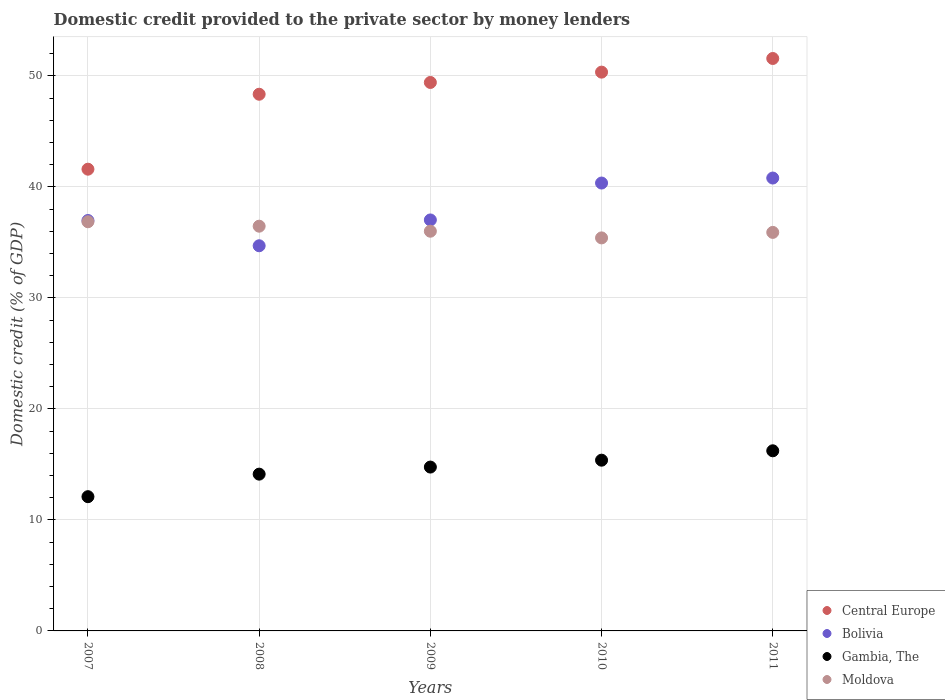What is the domestic credit provided to the private sector by money lenders in Moldova in 2011?
Ensure brevity in your answer.  35.9. Across all years, what is the maximum domestic credit provided to the private sector by money lenders in Central Europe?
Offer a terse response. 51.56. Across all years, what is the minimum domestic credit provided to the private sector by money lenders in Bolivia?
Provide a succinct answer. 34.69. What is the total domestic credit provided to the private sector by money lenders in Moldova in the graph?
Ensure brevity in your answer.  180.61. What is the difference between the domestic credit provided to the private sector by money lenders in Central Europe in 2008 and that in 2011?
Your answer should be compact. -3.22. What is the difference between the domestic credit provided to the private sector by money lenders in Gambia, The in 2009 and the domestic credit provided to the private sector by money lenders in Moldova in 2008?
Make the answer very short. -21.7. What is the average domestic credit provided to the private sector by money lenders in Central Europe per year?
Your answer should be very brief. 48.25. In the year 2007, what is the difference between the domestic credit provided to the private sector by money lenders in Moldova and domestic credit provided to the private sector by money lenders in Gambia, The?
Make the answer very short. 24.76. In how many years, is the domestic credit provided to the private sector by money lenders in Bolivia greater than 24 %?
Provide a short and direct response. 5. What is the ratio of the domestic credit provided to the private sector by money lenders in Moldova in 2007 to that in 2010?
Your response must be concise. 1.04. Is the domestic credit provided to the private sector by money lenders in Central Europe in 2007 less than that in 2011?
Your answer should be very brief. Yes. Is the difference between the domestic credit provided to the private sector by money lenders in Moldova in 2007 and 2008 greater than the difference between the domestic credit provided to the private sector by money lenders in Gambia, The in 2007 and 2008?
Keep it short and to the point. Yes. What is the difference between the highest and the second highest domestic credit provided to the private sector by money lenders in Gambia, The?
Provide a short and direct response. 0.85. What is the difference between the highest and the lowest domestic credit provided to the private sector by money lenders in Central Europe?
Your answer should be compact. 9.97. In how many years, is the domestic credit provided to the private sector by money lenders in Gambia, The greater than the average domestic credit provided to the private sector by money lenders in Gambia, The taken over all years?
Offer a terse response. 3. Is the sum of the domestic credit provided to the private sector by money lenders in Moldova in 2010 and 2011 greater than the maximum domestic credit provided to the private sector by money lenders in Central Europe across all years?
Your answer should be compact. Yes. Is it the case that in every year, the sum of the domestic credit provided to the private sector by money lenders in Bolivia and domestic credit provided to the private sector by money lenders in Gambia, The  is greater than the domestic credit provided to the private sector by money lenders in Moldova?
Your answer should be very brief. Yes. Is the domestic credit provided to the private sector by money lenders in Bolivia strictly less than the domestic credit provided to the private sector by money lenders in Moldova over the years?
Ensure brevity in your answer.  No. How many years are there in the graph?
Your answer should be very brief. 5. What is the difference between two consecutive major ticks on the Y-axis?
Offer a terse response. 10. Does the graph contain any zero values?
Make the answer very short. No. Does the graph contain grids?
Give a very brief answer. Yes. How are the legend labels stacked?
Your answer should be very brief. Vertical. What is the title of the graph?
Offer a very short reply. Domestic credit provided to the private sector by money lenders. Does "American Samoa" appear as one of the legend labels in the graph?
Your response must be concise. No. What is the label or title of the Y-axis?
Offer a terse response. Domestic credit (% of GDP). What is the Domestic credit (% of GDP) of Central Europe in 2007?
Give a very brief answer. 41.59. What is the Domestic credit (% of GDP) in Bolivia in 2007?
Give a very brief answer. 36.97. What is the Domestic credit (% of GDP) in Gambia, The in 2007?
Ensure brevity in your answer.  12.09. What is the Domestic credit (% of GDP) in Moldova in 2007?
Offer a very short reply. 36.86. What is the Domestic credit (% of GDP) in Central Europe in 2008?
Your answer should be compact. 48.34. What is the Domestic credit (% of GDP) in Bolivia in 2008?
Provide a succinct answer. 34.69. What is the Domestic credit (% of GDP) of Gambia, The in 2008?
Your answer should be very brief. 14.12. What is the Domestic credit (% of GDP) of Moldova in 2008?
Offer a terse response. 36.46. What is the Domestic credit (% of GDP) in Central Europe in 2009?
Provide a succinct answer. 49.4. What is the Domestic credit (% of GDP) of Bolivia in 2009?
Give a very brief answer. 37.02. What is the Domestic credit (% of GDP) of Gambia, The in 2009?
Your answer should be compact. 14.76. What is the Domestic credit (% of GDP) in Moldova in 2009?
Your response must be concise. 36. What is the Domestic credit (% of GDP) in Central Europe in 2010?
Make the answer very short. 50.33. What is the Domestic credit (% of GDP) in Bolivia in 2010?
Offer a very short reply. 40.34. What is the Domestic credit (% of GDP) in Gambia, The in 2010?
Provide a succinct answer. 15.38. What is the Domestic credit (% of GDP) of Moldova in 2010?
Keep it short and to the point. 35.4. What is the Domestic credit (% of GDP) of Central Europe in 2011?
Your response must be concise. 51.56. What is the Domestic credit (% of GDP) in Bolivia in 2011?
Ensure brevity in your answer.  40.79. What is the Domestic credit (% of GDP) in Gambia, The in 2011?
Make the answer very short. 16.22. What is the Domestic credit (% of GDP) in Moldova in 2011?
Your answer should be very brief. 35.9. Across all years, what is the maximum Domestic credit (% of GDP) in Central Europe?
Give a very brief answer. 51.56. Across all years, what is the maximum Domestic credit (% of GDP) of Bolivia?
Ensure brevity in your answer.  40.79. Across all years, what is the maximum Domestic credit (% of GDP) in Gambia, The?
Offer a very short reply. 16.22. Across all years, what is the maximum Domestic credit (% of GDP) of Moldova?
Give a very brief answer. 36.86. Across all years, what is the minimum Domestic credit (% of GDP) in Central Europe?
Provide a succinct answer. 41.59. Across all years, what is the minimum Domestic credit (% of GDP) in Bolivia?
Make the answer very short. 34.69. Across all years, what is the minimum Domestic credit (% of GDP) in Gambia, The?
Offer a terse response. 12.09. Across all years, what is the minimum Domestic credit (% of GDP) in Moldova?
Your answer should be compact. 35.4. What is the total Domestic credit (% of GDP) of Central Europe in the graph?
Provide a succinct answer. 241.23. What is the total Domestic credit (% of GDP) in Bolivia in the graph?
Ensure brevity in your answer.  189.81. What is the total Domestic credit (% of GDP) of Gambia, The in the graph?
Make the answer very short. 72.58. What is the total Domestic credit (% of GDP) of Moldova in the graph?
Your response must be concise. 180.61. What is the difference between the Domestic credit (% of GDP) of Central Europe in 2007 and that in 2008?
Your answer should be very brief. -6.75. What is the difference between the Domestic credit (% of GDP) of Bolivia in 2007 and that in 2008?
Make the answer very short. 2.28. What is the difference between the Domestic credit (% of GDP) of Gambia, The in 2007 and that in 2008?
Your answer should be very brief. -2.03. What is the difference between the Domestic credit (% of GDP) in Moldova in 2007 and that in 2008?
Your answer should be very brief. 0.4. What is the difference between the Domestic credit (% of GDP) in Central Europe in 2007 and that in 2009?
Offer a terse response. -7.81. What is the difference between the Domestic credit (% of GDP) in Bolivia in 2007 and that in 2009?
Keep it short and to the point. -0.05. What is the difference between the Domestic credit (% of GDP) of Gambia, The in 2007 and that in 2009?
Keep it short and to the point. -2.67. What is the difference between the Domestic credit (% of GDP) in Moldova in 2007 and that in 2009?
Provide a succinct answer. 0.85. What is the difference between the Domestic credit (% of GDP) of Central Europe in 2007 and that in 2010?
Ensure brevity in your answer.  -8.74. What is the difference between the Domestic credit (% of GDP) of Bolivia in 2007 and that in 2010?
Offer a terse response. -3.37. What is the difference between the Domestic credit (% of GDP) of Gambia, The in 2007 and that in 2010?
Ensure brevity in your answer.  -3.29. What is the difference between the Domestic credit (% of GDP) in Moldova in 2007 and that in 2010?
Offer a terse response. 1.45. What is the difference between the Domestic credit (% of GDP) in Central Europe in 2007 and that in 2011?
Keep it short and to the point. -9.97. What is the difference between the Domestic credit (% of GDP) in Bolivia in 2007 and that in 2011?
Your answer should be compact. -3.82. What is the difference between the Domestic credit (% of GDP) in Gambia, The in 2007 and that in 2011?
Keep it short and to the point. -4.13. What is the difference between the Domestic credit (% of GDP) of Moldova in 2007 and that in 2011?
Your response must be concise. 0.96. What is the difference between the Domestic credit (% of GDP) in Central Europe in 2008 and that in 2009?
Your answer should be compact. -1.06. What is the difference between the Domestic credit (% of GDP) of Bolivia in 2008 and that in 2009?
Offer a terse response. -2.33. What is the difference between the Domestic credit (% of GDP) of Gambia, The in 2008 and that in 2009?
Make the answer very short. -0.64. What is the difference between the Domestic credit (% of GDP) of Moldova in 2008 and that in 2009?
Your answer should be compact. 0.45. What is the difference between the Domestic credit (% of GDP) in Central Europe in 2008 and that in 2010?
Offer a terse response. -1.99. What is the difference between the Domestic credit (% of GDP) in Bolivia in 2008 and that in 2010?
Offer a terse response. -5.65. What is the difference between the Domestic credit (% of GDP) of Gambia, The in 2008 and that in 2010?
Ensure brevity in your answer.  -1.26. What is the difference between the Domestic credit (% of GDP) of Moldova in 2008 and that in 2010?
Offer a very short reply. 1.05. What is the difference between the Domestic credit (% of GDP) in Central Europe in 2008 and that in 2011?
Give a very brief answer. -3.22. What is the difference between the Domestic credit (% of GDP) in Bolivia in 2008 and that in 2011?
Provide a succinct answer. -6.1. What is the difference between the Domestic credit (% of GDP) of Gambia, The in 2008 and that in 2011?
Your answer should be compact. -2.1. What is the difference between the Domestic credit (% of GDP) in Moldova in 2008 and that in 2011?
Provide a short and direct response. 0.56. What is the difference between the Domestic credit (% of GDP) in Central Europe in 2009 and that in 2010?
Provide a short and direct response. -0.93. What is the difference between the Domestic credit (% of GDP) in Bolivia in 2009 and that in 2010?
Your response must be concise. -3.32. What is the difference between the Domestic credit (% of GDP) in Gambia, The in 2009 and that in 2010?
Ensure brevity in your answer.  -0.62. What is the difference between the Domestic credit (% of GDP) of Moldova in 2009 and that in 2010?
Your answer should be compact. 0.6. What is the difference between the Domestic credit (% of GDP) in Central Europe in 2009 and that in 2011?
Offer a very short reply. -2.16. What is the difference between the Domestic credit (% of GDP) of Bolivia in 2009 and that in 2011?
Provide a short and direct response. -3.77. What is the difference between the Domestic credit (% of GDP) of Gambia, The in 2009 and that in 2011?
Offer a very short reply. -1.47. What is the difference between the Domestic credit (% of GDP) in Moldova in 2009 and that in 2011?
Ensure brevity in your answer.  0.11. What is the difference between the Domestic credit (% of GDP) of Central Europe in 2010 and that in 2011?
Your response must be concise. -1.23. What is the difference between the Domestic credit (% of GDP) in Bolivia in 2010 and that in 2011?
Make the answer very short. -0.45. What is the difference between the Domestic credit (% of GDP) in Gambia, The in 2010 and that in 2011?
Your answer should be very brief. -0.85. What is the difference between the Domestic credit (% of GDP) of Moldova in 2010 and that in 2011?
Your response must be concise. -0.5. What is the difference between the Domestic credit (% of GDP) in Central Europe in 2007 and the Domestic credit (% of GDP) in Bolivia in 2008?
Make the answer very short. 6.9. What is the difference between the Domestic credit (% of GDP) of Central Europe in 2007 and the Domestic credit (% of GDP) of Gambia, The in 2008?
Keep it short and to the point. 27.47. What is the difference between the Domestic credit (% of GDP) of Central Europe in 2007 and the Domestic credit (% of GDP) of Moldova in 2008?
Keep it short and to the point. 5.13. What is the difference between the Domestic credit (% of GDP) of Bolivia in 2007 and the Domestic credit (% of GDP) of Gambia, The in 2008?
Keep it short and to the point. 22.85. What is the difference between the Domestic credit (% of GDP) of Bolivia in 2007 and the Domestic credit (% of GDP) of Moldova in 2008?
Offer a very short reply. 0.51. What is the difference between the Domestic credit (% of GDP) in Gambia, The in 2007 and the Domestic credit (% of GDP) in Moldova in 2008?
Offer a very short reply. -24.36. What is the difference between the Domestic credit (% of GDP) in Central Europe in 2007 and the Domestic credit (% of GDP) in Bolivia in 2009?
Provide a short and direct response. 4.57. What is the difference between the Domestic credit (% of GDP) of Central Europe in 2007 and the Domestic credit (% of GDP) of Gambia, The in 2009?
Offer a very short reply. 26.83. What is the difference between the Domestic credit (% of GDP) in Central Europe in 2007 and the Domestic credit (% of GDP) in Moldova in 2009?
Provide a succinct answer. 5.59. What is the difference between the Domestic credit (% of GDP) in Bolivia in 2007 and the Domestic credit (% of GDP) in Gambia, The in 2009?
Keep it short and to the point. 22.21. What is the difference between the Domestic credit (% of GDP) of Bolivia in 2007 and the Domestic credit (% of GDP) of Moldova in 2009?
Give a very brief answer. 0.97. What is the difference between the Domestic credit (% of GDP) in Gambia, The in 2007 and the Domestic credit (% of GDP) in Moldova in 2009?
Give a very brief answer. -23.91. What is the difference between the Domestic credit (% of GDP) of Central Europe in 2007 and the Domestic credit (% of GDP) of Bolivia in 2010?
Provide a succinct answer. 1.25. What is the difference between the Domestic credit (% of GDP) of Central Europe in 2007 and the Domestic credit (% of GDP) of Gambia, The in 2010?
Your response must be concise. 26.21. What is the difference between the Domestic credit (% of GDP) of Central Europe in 2007 and the Domestic credit (% of GDP) of Moldova in 2010?
Your answer should be compact. 6.19. What is the difference between the Domestic credit (% of GDP) in Bolivia in 2007 and the Domestic credit (% of GDP) in Gambia, The in 2010?
Keep it short and to the point. 21.59. What is the difference between the Domestic credit (% of GDP) in Bolivia in 2007 and the Domestic credit (% of GDP) in Moldova in 2010?
Your response must be concise. 1.57. What is the difference between the Domestic credit (% of GDP) of Gambia, The in 2007 and the Domestic credit (% of GDP) of Moldova in 2010?
Give a very brief answer. -23.31. What is the difference between the Domestic credit (% of GDP) of Central Europe in 2007 and the Domestic credit (% of GDP) of Bolivia in 2011?
Make the answer very short. 0.8. What is the difference between the Domestic credit (% of GDP) in Central Europe in 2007 and the Domestic credit (% of GDP) in Gambia, The in 2011?
Provide a short and direct response. 25.37. What is the difference between the Domestic credit (% of GDP) in Central Europe in 2007 and the Domestic credit (% of GDP) in Moldova in 2011?
Your answer should be very brief. 5.69. What is the difference between the Domestic credit (% of GDP) in Bolivia in 2007 and the Domestic credit (% of GDP) in Gambia, The in 2011?
Provide a short and direct response. 20.74. What is the difference between the Domestic credit (% of GDP) in Bolivia in 2007 and the Domestic credit (% of GDP) in Moldova in 2011?
Your answer should be compact. 1.07. What is the difference between the Domestic credit (% of GDP) of Gambia, The in 2007 and the Domestic credit (% of GDP) of Moldova in 2011?
Make the answer very short. -23.8. What is the difference between the Domestic credit (% of GDP) of Central Europe in 2008 and the Domestic credit (% of GDP) of Bolivia in 2009?
Your answer should be very brief. 11.32. What is the difference between the Domestic credit (% of GDP) in Central Europe in 2008 and the Domestic credit (% of GDP) in Gambia, The in 2009?
Provide a short and direct response. 33.58. What is the difference between the Domestic credit (% of GDP) of Central Europe in 2008 and the Domestic credit (% of GDP) of Moldova in 2009?
Keep it short and to the point. 12.34. What is the difference between the Domestic credit (% of GDP) of Bolivia in 2008 and the Domestic credit (% of GDP) of Gambia, The in 2009?
Your answer should be compact. 19.93. What is the difference between the Domestic credit (% of GDP) in Bolivia in 2008 and the Domestic credit (% of GDP) in Moldova in 2009?
Ensure brevity in your answer.  -1.31. What is the difference between the Domestic credit (% of GDP) in Gambia, The in 2008 and the Domestic credit (% of GDP) in Moldova in 2009?
Offer a very short reply. -21.88. What is the difference between the Domestic credit (% of GDP) in Central Europe in 2008 and the Domestic credit (% of GDP) in Bolivia in 2010?
Make the answer very short. 8. What is the difference between the Domestic credit (% of GDP) in Central Europe in 2008 and the Domestic credit (% of GDP) in Gambia, The in 2010?
Give a very brief answer. 32.96. What is the difference between the Domestic credit (% of GDP) in Central Europe in 2008 and the Domestic credit (% of GDP) in Moldova in 2010?
Give a very brief answer. 12.94. What is the difference between the Domestic credit (% of GDP) in Bolivia in 2008 and the Domestic credit (% of GDP) in Gambia, The in 2010?
Offer a very short reply. 19.31. What is the difference between the Domestic credit (% of GDP) of Bolivia in 2008 and the Domestic credit (% of GDP) of Moldova in 2010?
Provide a succinct answer. -0.71. What is the difference between the Domestic credit (% of GDP) of Gambia, The in 2008 and the Domestic credit (% of GDP) of Moldova in 2010?
Make the answer very short. -21.28. What is the difference between the Domestic credit (% of GDP) in Central Europe in 2008 and the Domestic credit (% of GDP) in Bolivia in 2011?
Give a very brief answer. 7.55. What is the difference between the Domestic credit (% of GDP) in Central Europe in 2008 and the Domestic credit (% of GDP) in Gambia, The in 2011?
Ensure brevity in your answer.  32.12. What is the difference between the Domestic credit (% of GDP) in Central Europe in 2008 and the Domestic credit (% of GDP) in Moldova in 2011?
Keep it short and to the point. 12.44. What is the difference between the Domestic credit (% of GDP) in Bolivia in 2008 and the Domestic credit (% of GDP) in Gambia, The in 2011?
Offer a very short reply. 18.47. What is the difference between the Domestic credit (% of GDP) in Bolivia in 2008 and the Domestic credit (% of GDP) in Moldova in 2011?
Your response must be concise. -1.2. What is the difference between the Domestic credit (% of GDP) of Gambia, The in 2008 and the Domestic credit (% of GDP) of Moldova in 2011?
Offer a terse response. -21.77. What is the difference between the Domestic credit (% of GDP) of Central Europe in 2009 and the Domestic credit (% of GDP) of Bolivia in 2010?
Provide a succinct answer. 9.06. What is the difference between the Domestic credit (% of GDP) of Central Europe in 2009 and the Domestic credit (% of GDP) of Gambia, The in 2010?
Offer a terse response. 34.02. What is the difference between the Domestic credit (% of GDP) in Central Europe in 2009 and the Domestic credit (% of GDP) in Moldova in 2010?
Make the answer very short. 14. What is the difference between the Domestic credit (% of GDP) of Bolivia in 2009 and the Domestic credit (% of GDP) of Gambia, The in 2010?
Give a very brief answer. 21.64. What is the difference between the Domestic credit (% of GDP) in Bolivia in 2009 and the Domestic credit (% of GDP) in Moldova in 2010?
Provide a succinct answer. 1.62. What is the difference between the Domestic credit (% of GDP) in Gambia, The in 2009 and the Domestic credit (% of GDP) in Moldova in 2010?
Make the answer very short. -20.64. What is the difference between the Domestic credit (% of GDP) of Central Europe in 2009 and the Domestic credit (% of GDP) of Bolivia in 2011?
Ensure brevity in your answer.  8.61. What is the difference between the Domestic credit (% of GDP) in Central Europe in 2009 and the Domestic credit (% of GDP) in Gambia, The in 2011?
Make the answer very short. 33.18. What is the difference between the Domestic credit (% of GDP) of Central Europe in 2009 and the Domestic credit (% of GDP) of Moldova in 2011?
Your answer should be very brief. 13.51. What is the difference between the Domestic credit (% of GDP) of Bolivia in 2009 and the Domestic credit (% of GDP) of Gambia, The in 2011?
Offer a terse response. 20.79. What is the difference between the Domestic credit (% of GDP) of Bolivia in 2009 and the Domestic credit (% of GDP) of Moldova in 2011?
Ensure brevity in your answer.  1.12. What is the difference between the Domestic credit (% of GDP) of Gambia, The in 2009 and the Domestic credit (% of GDP) of Moldova in 2011?
Your answer should be compact. -21.14. What is the difference between the Domestic credit (% of GDP) in Central Europe in 2010 and the Domestic credit (% of GDP) in Bolivia in 2011?
Provide a succinct answer. 9.54. What is the difference between the Domestic credit (% of GDP) in Central Europe in 2010 and the Domestic credit (% of GDP) in Gambia, The in 2011?
Provide a succinct answer. 34.11. What is the difference between the Domestic credit (% of GDP) in Central Europe in 2010 and the Domestic credit (% of GDP) in Moldova in 2011?
Give a very brief answer. 14.44. What is the difference between the Domestic credit (% of GDP) in Bolivia in 2010 and the Domestic credit (% of GDP) in Gambia, The in 2011?
Provide a short and direct response. 24.12. What is the difference between the Domestic credit (% of GDP) in Bolivia in 2010 and the Domestic credit (% of GDP) in Moldova in 2011?
Give a very brief answer. 4.45. What is the difference between the Domestic credit (% of GDP) in Gambia, The in 2010 and the Domestic credit (% of GDP) in Moldova in 2011?
Provide a short and direct response. -20.52. What is the average Domestic credit (% of GDP) in Central Europe per year?
Give a very brief answer. 48.25. What is the average Domestic credit (% of GDP) in Bolivia per year?
Offer a terse response. 37.96. What is the average Domestic credit (% of GDP) of Gambia, The per year?
Your answer should be very brief. 14.52. What is the average Domestic credit (% of GDP) of Moldova per year?
Your response must be concise. 36.12. In the year 2007, what is the difference between the Domestic credit (% of GDP) in Central Europe and Domestic credit (% of GDP) in Bolivia?
Provide a short and direct response. 4.62. In the year 2007, what is the difference between the Domestic credit (% of GDP) in Central Europe and Domestic credit (% of GDP) in Gambia, The?
Give a very brief answer. 29.5. In the year 2007, what is the difference between the Domestic credit (% of GDP) in Central Europe and Domestic credit (% of GDP) in Moldova?
Keep it short and to the point. 4.73. In the year 2007, what is the difference between the Domestic credit (% of GDP) of Bolivia and Domestic credit (% of GDP) of Gambia, The?
Make the answer very short. 24.88. In the year 2007, what is the difference between the Domestic credit (% of GDP) in Bolivia and Domestic credit (% of GDP) in Moldova?
Make the answer very short. 0.11. In the year 2007, what is the difference between the Domestic credit (% of GDP) in Gambia, The and Domestic credit (% of GDP) in Moldova?
Offer a very short reply. -24.76. In the year 2008, what is the difference between the Domestic credit (% of GDP) in Central Europe and Domestic credit (% of GDP) in Bolivia?
Provide a short and direct response. 13.65. In the year 2008, what is the difference between the Domestic credit (% of GDP) of Central Europe and Domestic credit (% of GDP) of Gambia, The?
Keep it short and to the point. 34.22. In the year 2008, what is the difference between the Domestic credit (% of GDP) in Central Europe and Domestic credit (% of GDP) in Moldova?
Keep it short and to the point. 11.89. In the year 2008, what is the difference between the Domestic credit (% of GDP) of Bolivia and Domestic credit (% of GDP) of Gambia, The?
Your response must be concise. 20.57. In the year 2008, what is the difference between the Domestic credit (% of GDP) in Bolivia and Domestic credit (% of GDP) in Moldova?
Ensure brevity in your answer.  -1.76. In the year 2008, what is the difference between the Domestic credit (% of GDP) of Gambia, The and Domestic credit (% of GDP) of Moldova?
Offer a terse response. -22.33. In the year 2009, what is the difference between the Domestic credit (% of GDP) of Central Europe and Domestic credit (% of GDP) of Bolivia?
Make the answer very short. 12.38. In the year 2009, what is the difference between the Domestic credit (% of GDP) of Central Europe and Domestic credit (% of GDP) of Gambia, The?
Give a very brief answer. 34.64. In the year 2009, what is the difference between the Domestic credit (% of GDP) of Central Europe and Domestic credit (% of GDP) of Moldova?
Ensure brevity in your answer.  13.4. In the year 2009, what is the difference between the Domestic credit (% of GDP) in Bolivia and Domestic credit (% of GDP) in Gambia, The?
Make the answer very short. 22.26. In the year 2009, what is the difference between the Domestic credit (% of GDP) in Bolivia and Domestic credit (% of GDP) in Moldova?
Offer a terse response. 1.02. In the year 2009, what is the difference between the Domestic credit (% of GDP) of Gambia, The and Domestic credit (% of GDP) of Moldova?
Your answer should be very brief. -21.24. In the year 2010, what is the difference between the Domestic credit (% of GDP) of Central Europe and Domestic credit (% of GDP) of Bolivia?
Offer a terse response. 9.99. In the year 2010, what is the difference between the Domestic credit (% of GDP) in Central Europe and Domestic credit (% of GDP) in Gambia, The?
Your answer should be very brief. 34.95. In the year 2010, what is the difference between the Domestic credit (% of GDP) in Central Europe and Domestic credit (% of GDP) in Moldova?
Offer a terse response. 14.93. In the year 2010, what is the difference between the Domestic credit (% of GDP) in Bolivia and Domestic credit (% of GDP) in Gambia, The?
Offer a very short reply. 24.96. In the year 2010, what is the difference between the Domestic credit (% of GDP) of Bolivia and Domestic credit (% of GDP) of Moldova?
Offer a very short reply. 4.94. In the year 2010, what is the difference between the Domestic credit (% of GDP) of Gambia, The and Domestic credit (% of GDP) of Moldova?
Your answer should be very brief. -20.02. In the year 2011, what is the difference between the Domestic credit (% of GDP) of Central Europe and Domestic credit (% of GDP) of Bolivia?
Ensure brevity in your answer.  10.77. In the year 2011, what is the difference between the Domestic credit (% of GDP) of Central Europe and Domestic credit (% of GDP) of Gambia, The?
Give a very brief answer. 35.34. In the year 2011, what is the difference between the Domestic credit (% of GDP) of Central Europe and Domestic credit (% of GDP) of Moldova?
Offer a terse response. 15.66. In the year 2011, what is the difference between the Domestic credit (% of GDP) in Bolivia and Domestic credit (% of GDP) in Gambia, The?
Offer a very short reply. 24.57. In the year 2011, what is the difference between the Domestic credit (% of GDP) of Bolivia and Domestic credit (% of GDP) of Moldova?
Provide a succinct answer. 4.9. In the year 2011, what is the difference between the Domestic credit (% of GDP) of Gambia, The and Domestic credit (% of GDP) of Moldova?
Offer a very short reply. -19.67. What is the ratio of the Domestic credit (% of GDP) in Central Europe in 2007 to that in 2008?
Your answer should be compact. 0.86. What is the ratio of the Domestic credit (% of GDP) of Bolivia in 2007 to that in 2008?
Offer a terse response. 1.07. What is the ratio of the Domestic credit (% of GDP) in Gambia, The in 2007 to that in 2008?
Keep it short and to the point. 0.86. What is the ratio of the Domestic credit (% of GDP) of Moldova in 2007 to that in 2008?
Keep it short and to the point. 1.01. What is the ratio of the Domestic credit (% of GDP) in Central Europe in 2007 to that in 2009?
Provide a short and direct response. 0.84. What is the ratio of the Domestic credit (% of GDP) of Gambia, The in 2007 to that in 2009?
Ensure brevity in your answer.  0.82. What is the ratio of the Domestic credit (% of GDP) of Moldova in 2007 to that in 2009?
Give a very brief answer. 1.02. What is the ratio of the Domestic credit (% of GDP) in Central Europe in 2007 to that in 2010?
Your response must be concise. 0.83. What is the ratio of the Domestic credit (% of GDP) of Bolivia in 2007 to that in 2010?
Give a very brief answer. 0.92. What is the ratio of the Domestic credit (% of GDP) of Gambia, The in 2007 to that in 2010?
Your answer should be compact. 0.79. What is the ratio of the Domestic credit (% of GDP) of Moldova in 2007 to that in 2010?
Give a very brief answer. 1.04. What is the ratio of the Domestic credit (% of GDP) in Central Europe in 2007 to that in 2011?
Your answer should be compact. 0.81. What is the ratio of the Domestic credit (% of GDP) of Bolivia in 2007 to that in 2011?
Offer a terse response. 0.91. What is the ratio of the Domestic credit (% of GDP) in Gambia, The in 2007 to that in 2011?
Give a very brief answer. 0.75. What is the ratio of the Domestic credit (% of GDP) in Moldova in 2007 to that in 2011?
Offer a terse response. 1.03. What is the ratio of the Domestic credit (% of GDP) of Central Europe in 2008 to that in 2009?
Provide a short and direct response. 0.98. What is the ratio of the Domestic credit (% of GDP) of Bolivia in 2008 to that in 2009?
Keep it short and to the point. 0.94. What is the ratio of the Domestic credit (% of GDP) of Gambia, The in 2008 to that in 2009?
Your answer should be compact. 0.96. What is the ratio of the Domestic credit (% of GDP) of Moldova in 2008 to that in 2009?
Offer a very short reply. 1.01. What is the ratio of the Domestic credit (% of GDP) in Central Europe in 2008 to that in 2010?
Your answer should be very brief. 0.96. What is the ratio of the Domestic credit (% of GDP) in Bolivia in 2008 to that in 2010?
Offer a terse response. 0.86. What is the ratio of the Domestic credit (% of GDP) in Gambia, The in 2008 to that in 2010?
Your response must be concise. 0.92. What is the ratio of the Domestic credit (% of GDP) in Moldova in 2008 to that in 2010?
Offer a terse response. 1.03. What is the ratio of the Domestic credit (% of GDP) of Bolivia in 2008 to that in 2011?
Give a very brief answer. 0.85. What is the ratio of the Domestic credit (% of GDP) in Gambia, The in 2008 to that in 2011?
Your response must be concise. 0.87. What is the ratio of the Domestic credit (% of GDP) in Moldova in 2008 to that in 2011?
Ensure brevity in your answer.  1.02. What is the ratio of the Domestic credit (% of GDP) in Central Europe in 2009 to that in 2010?
Make the answer very short. 0.98. What is the ratio of the Domestic credit (% of GDP) in Bolivia in 2009 to that in 2010?
Ensure brevity in your answer.  0.92. What is the ratio of the Domestic credit (% of GDP) of Gambia, The in 2009 to that in 2010?
Keep it short and to the point. 0.96. What is the ratio of the Domestic credit (% of GDP) in Central Europe in 2009 to that in 2011?
Offer a very short reply. 0.96. What is the ratio of the Domestic credit (% of GDP) of Bolivia in 2009 to that in 2011?
Your answer should be compact. 0.91. What is the ratio of the Domestic credit (% of GDP) in Gambia, The in 2009 to that in 2011?
Ensure brevity in your answer.  0.91. What is the ratio of the Domestic credit (% of GDP) in Central Europe in 2010 to that in 2011?
Provide a succinct answer. 0.98. What is the ratio of the Domestic credit (% of GDP) in Bolivia in 2010 to that in 2011?
Your answer should be very brief. 0.99. What is the ratio of the Domestic credit (% of GDP) of Gambia, The in 2010 to that in 2011?
Provide a short and direct response. 0.95. What is the ratio of the Domestic credit (% of GDP) of Moldova in 2010 to that in 2011?
Your response must be concise. 0.99. What is the difference between the highest and the second highest Domestic credit (% of GDP) of Central Europe?
Give a very brief answer. 1.23. What is the difference between the highest and the second highest Domestic credit (% of GDP) of Bolivia?
Offer a very short reply. 0.45. What is the difference between the highest and the second highest Domestic credit (% of GDP) in Gambia, The?
Give a very brief answer. 0.85. What is the difference between the highest and the second highest Domestic credit (% of GDP) of Moldova?
Offer a very short reply. 0.4. What is the difference between the highest and the lowest Domestic credit (% of GDP) of Central Europe?
Offer a very short reply. 9.97. What is the difference between the highest and the lowest Domestic credit (% of GDP) in Bolivia?
Provide a succinct answer. 6.1. What is the difference between the highest and the lowest Domestic credit (% of GDP) of Gambia, The?
Give a very brief answer. 4.13. What is the difference between the highest and the lowest Domestic credit (% of GDP) in Moldova?
Keep it short and to the point. 1.45. 